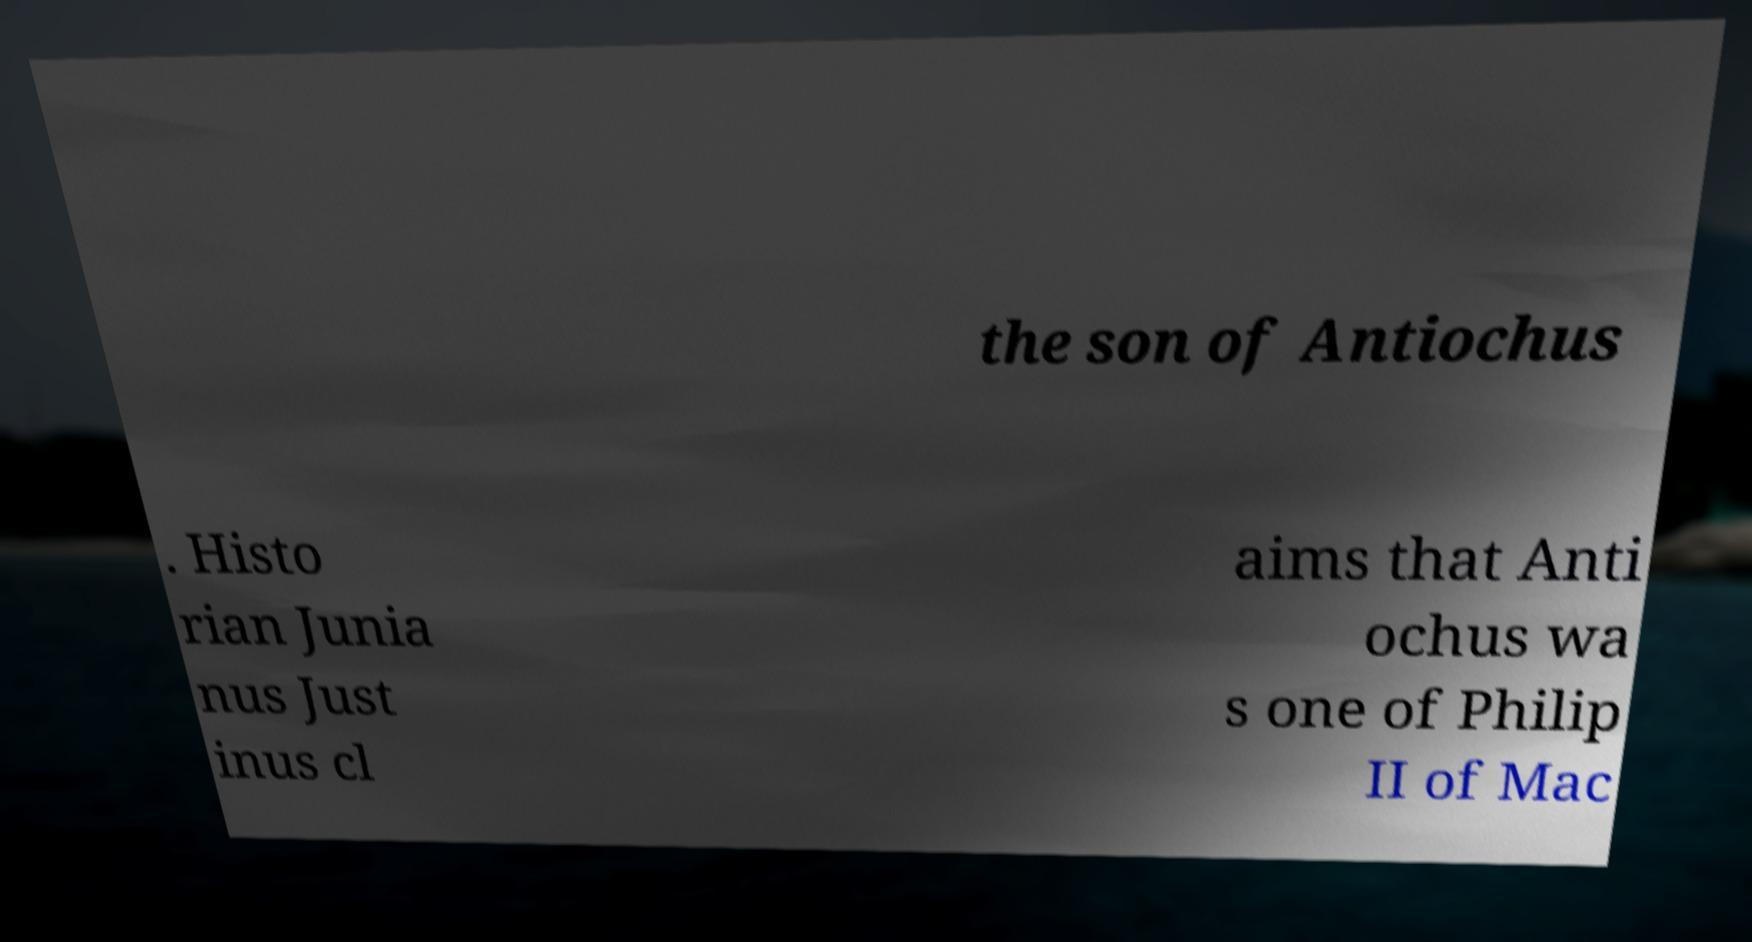Can you read and provide the text displayed in the image?This photo seems to have some interesting text. Can you extract and type it out for me? the son of Antiochus . Histo rian Junia nus Just inus cl aims that Anti ochus wa s one of Philip II of Mac 